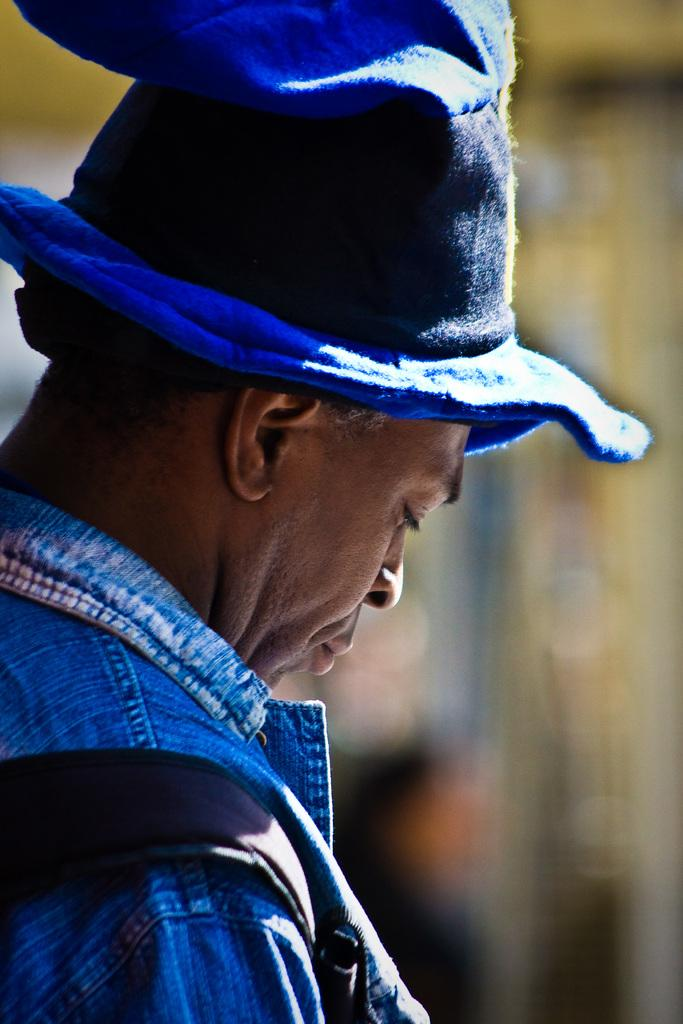What is present in the image? There is a person in the image. Can you describe the person's attire? The person is wearing clothes and a hat. What type of clouds can be seen in the image? There are no clouds visible in the image, as it only features a person wearing clothes and a hat. 